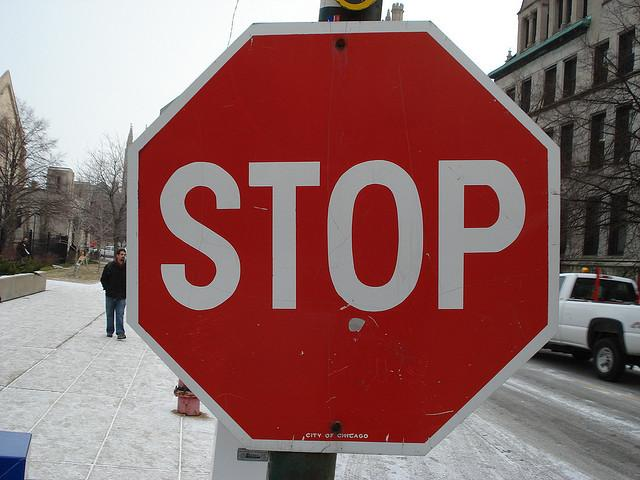This city's name comes from a Native American word for what?

Choices:
A) wind
B) onion
C) tomato
D) lake onion 